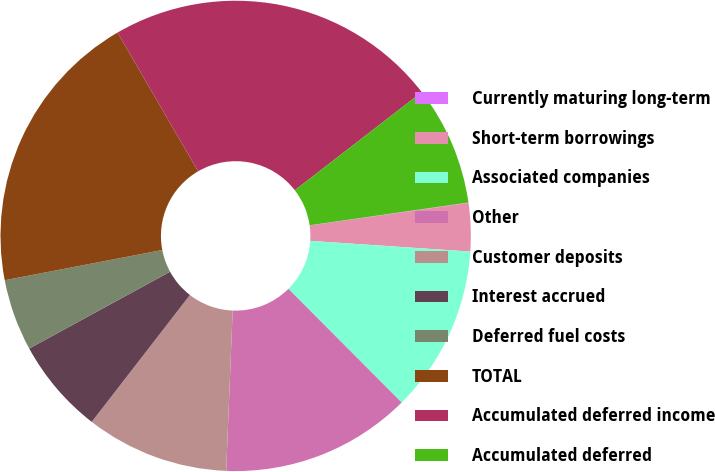Convert chart to OTSL. <chart><loc_0><loc_0><loc_500><loc_500><pie_chart><fcel>Currently maturing long-term<fcel>Short-term borrowings<fcel>Associated companies<fcel>Other<fcel>Customer deposits<fcel>Interest accrued<fcel>Deferred fuel costs<fcel>TOTAL<fcel>Accumulated deferred income<fcel>Accumulated deferred<nl><fcel>0.03%<fcel>3.3%<fcel>11.47%<fcel>13.11%<fcel>9.84%<fcel>6.57%<fcel>4.93%<fcel>19.64%<fcel>22.91%<fcel>8.2%<nl></chart> 